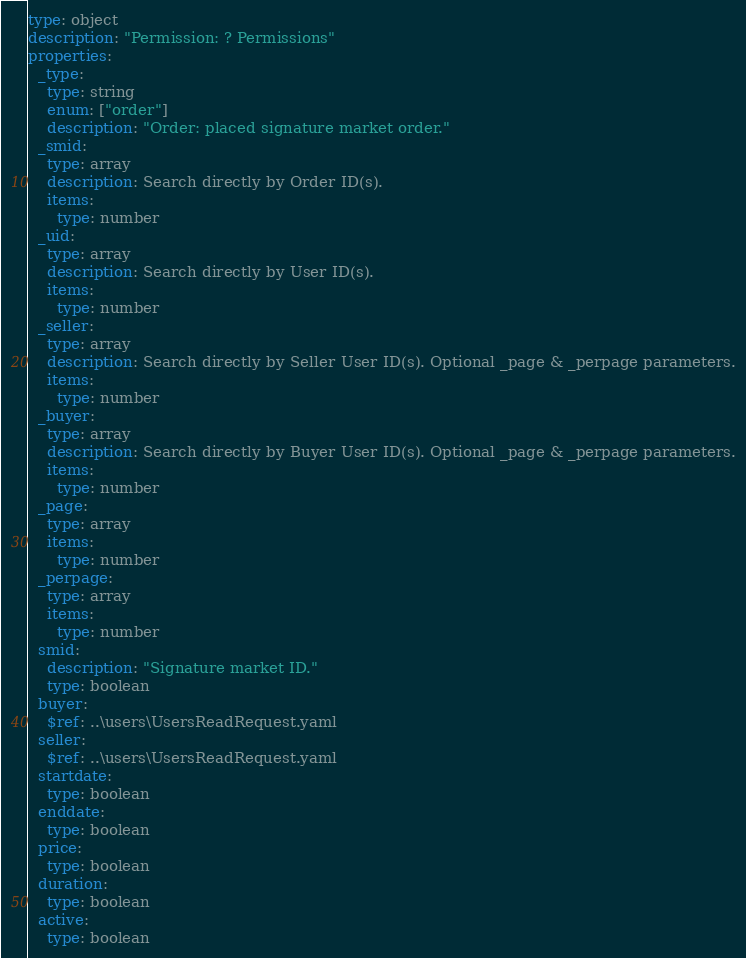Convert code to text. <code><loc_0><loc_0><loc_500><loc_500><_YAML_>type: object
description: "Permission: ? Permissions"
properties:
  _type:
    type: string
    enum: ["order"]
    description: "Order: placed signature market order."
  _smid:
    type: array
    description: Search directly by Order ID(s).
    items:
      type: number
  _uid:
    type: array
    description: Search directly by User ID(s).
    items:
      type: number
  _seller:
    type: array
    description: Search directly by Seller User ID(s). Optional _page & _perpage parameters.
    items:
      type: number
  _buyer:
    type: array
    description: Search directly by Buyer User ID(s). Optional _page & _perpage parameters.
    items:
      type: number
  _page:
    type: array
    items:
      type: number
  _perpage:
    type: array
    items:
      type: number
  smid:
    description: "Signature market ID."
    type: boolean
  buyer:
    $ref: ..\users\UsersReadRequest.yaml
  seller:
    $ref: ..\users\UsersReadRequest.yaml
  startdate:
    type: boolean
  enddate:
    type: boolean
  price:
    type: boolean
  duration:
    type: boolean
  active:
    type: boolean
</code> 